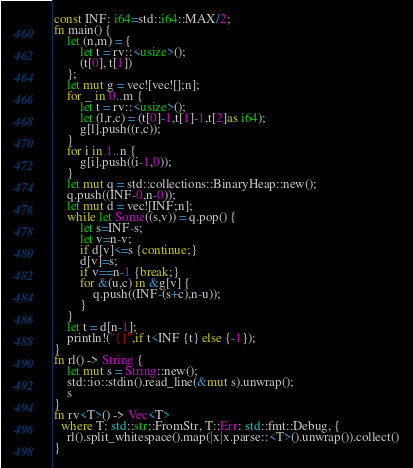<code> <loc_0><loc_0><loc_500><loc_500><_Rust_>const INF: i64=std::i64::MAX/2;
fn main() {
    let (n,m) = {
        let t = rv::<usize>();
        (t[0], t[1])
    };
    let mut g = vec![vec![];n];
    for _ in 0..m {
        let t = rv::<usize>();
        let (l,r,c) = (t[0]-1,t[1]-1,t[2]as i64);
        g[l].push((r,c));
    }
    for i in 1..n {
        g[i].push((i-1,0));
    }
    let mut q = std::collections::BinaryHeap::new();
    q.push((INF-0,n-0));
    let mut d = vec![INF;n];
    while let Some((s,v)) = q.pop() {
        let s=INF-s;
        let v=n-v;
        if d[v]<=s {continue;}
        d[v]=s;
        if v==n-1 {break;}
        for &(u,c) in &g[v] {
            q.push((INF-(s+c),n-u));
        }
    }
    let t = d[n-1];
    println!("{}",if t<INF {t} else {-1});
}
fn rl() -> String {
    let mut s = String::new();
    std::io::stdin().read_line(&mut s).unwrap();
    s
}
fn rv<T>() -> Vec<T>
  where T: std::str::FromStr, T::Err: std::fmt::Debug, {
    rl().split_whitespace().map(|x|x.parse::<T>().unwrap()).collect()
}</code> 